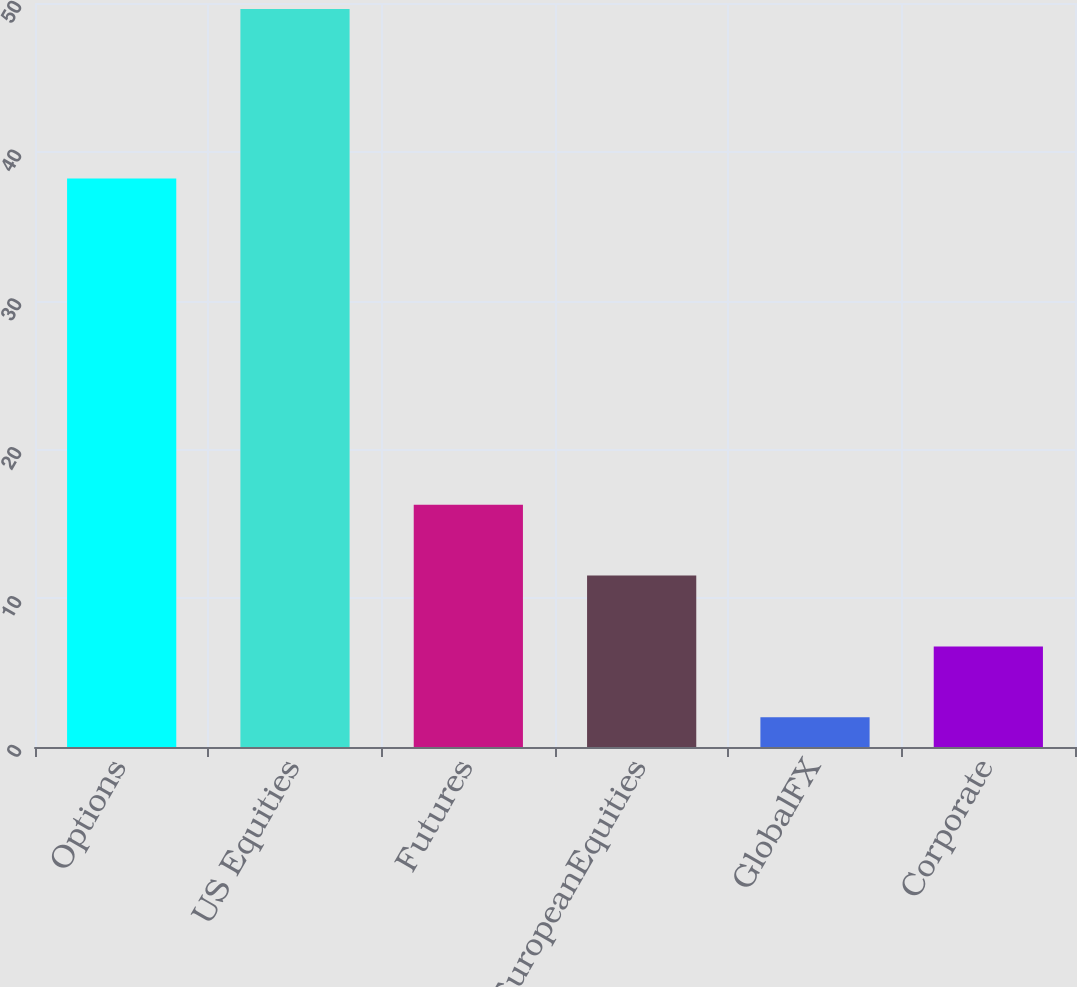Convert chart. <chart><loc_0><loc_0><loc_500><loc_500><bar_chart><fcel>Options<fcel>US Equities<fcel>Futures<fcel>EuropeanEquities<fcel>GlobalFX<fcel>Corporate<nl><fcel>38.2<fcel>49.6<fcel>16.28<fcel>11.52<fcel>2<fcel>6.76<nl></chart> 